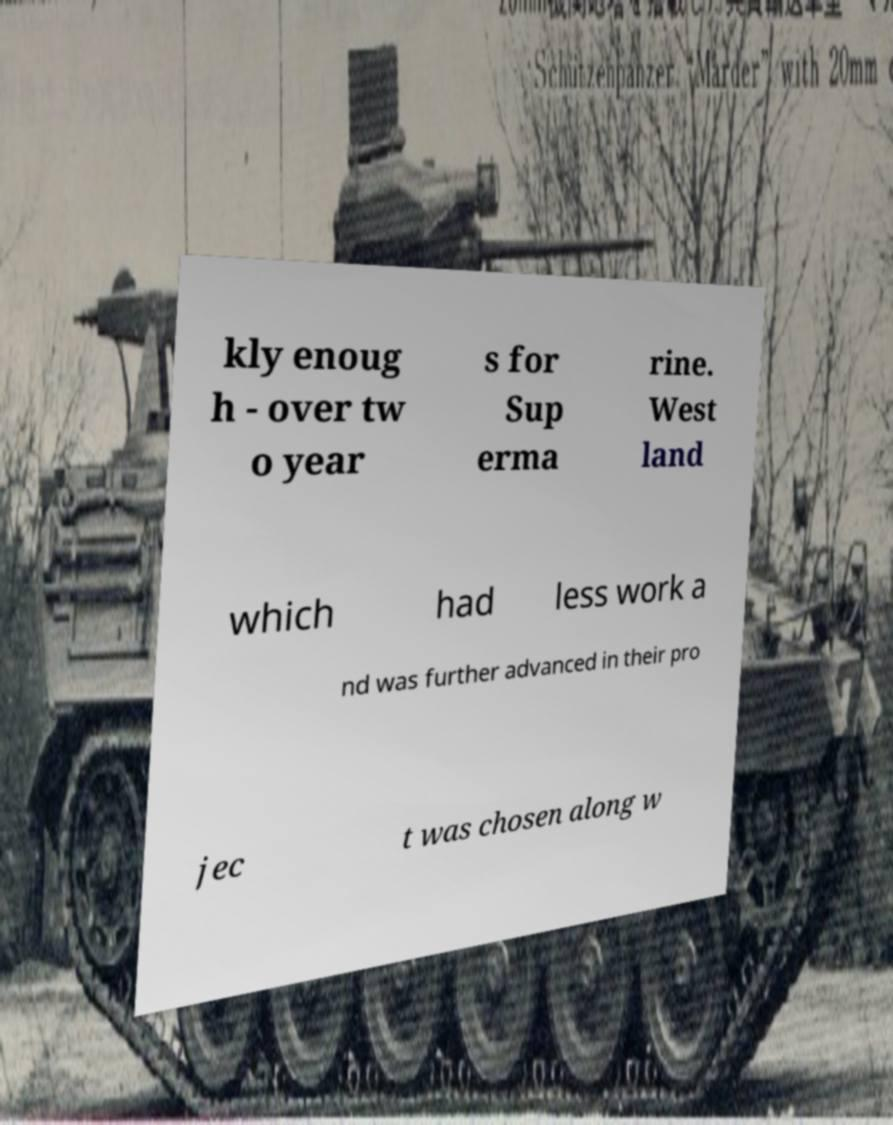Could you assist in decoding the text presented in this image and type it out clearly? kly enoug h - over tw o year s for Sup erma rine. West land which had less work a nd was further advanced in their pro jec t was chosen along w 